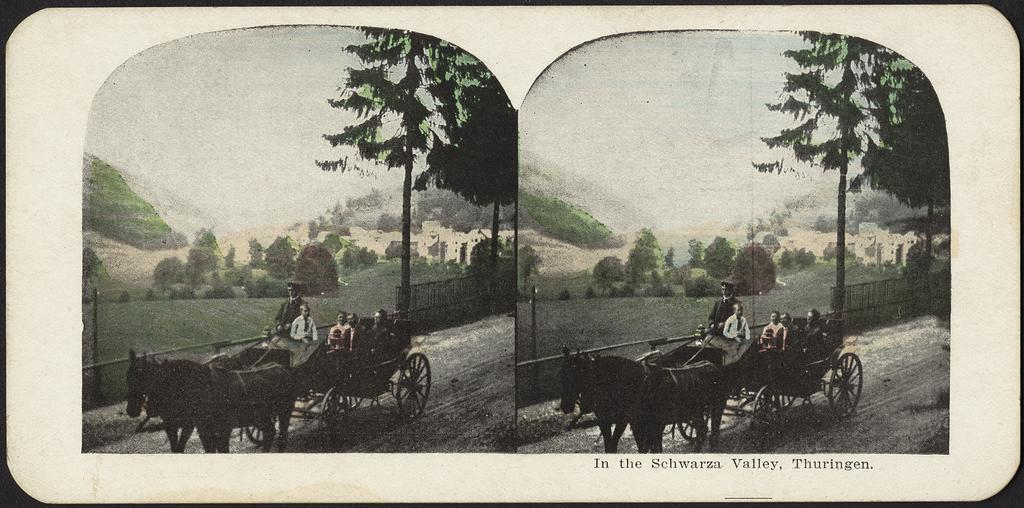What is the composition of the image? The image is a collage of two pictures. What is the main subject in the middle of the collage? There is a horse cart in the middle of the collage. Who is present in the horse cart? There are people sitting in the horse cart. What can be seen in the background of the collage? There are trees and hills in the background of the collage. What type of cloud is present in the image? There is no cloud present in the image; it is a collage of two pictures with a horse cart and people in the middle, and trees and hills in the background. 